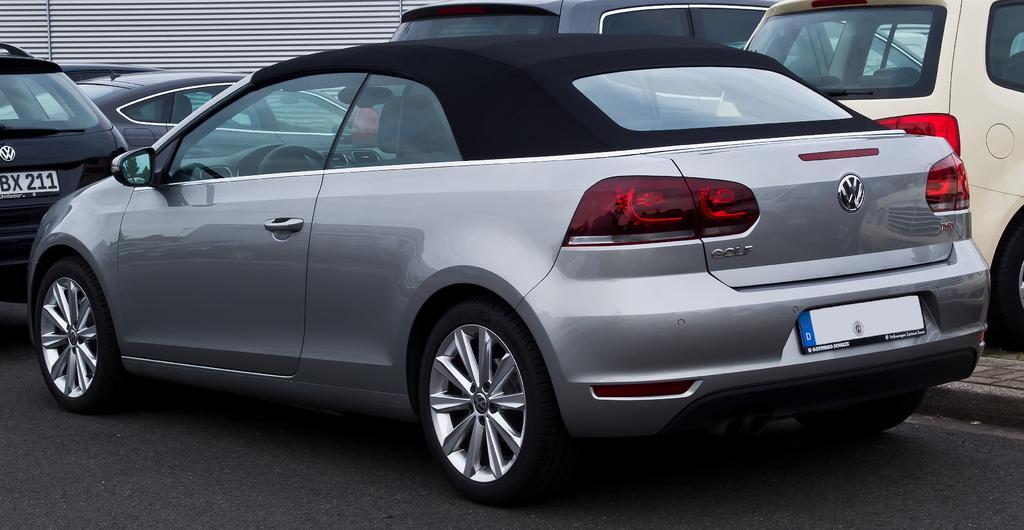Can you describe this image briefly? In this picture we can see a few vehicles on the road. We can see an object in the background. 